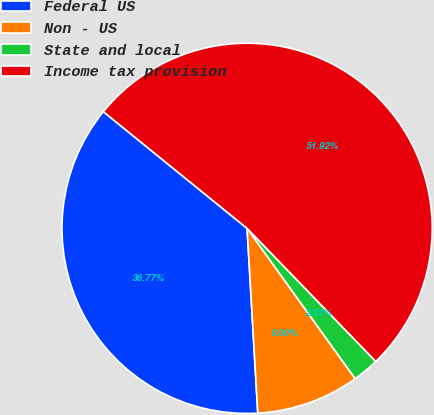<chart> <loc_0><loc_0><loc_500><loc_500><pie_chart><fcel>Federal US<fcel>Non - US<fcel>State and local<fcel>Income tax provision<nl><fcel>36.77%<fcel>9.0%<fcel>2.31%<fcel>51.91%<nl></chart> 